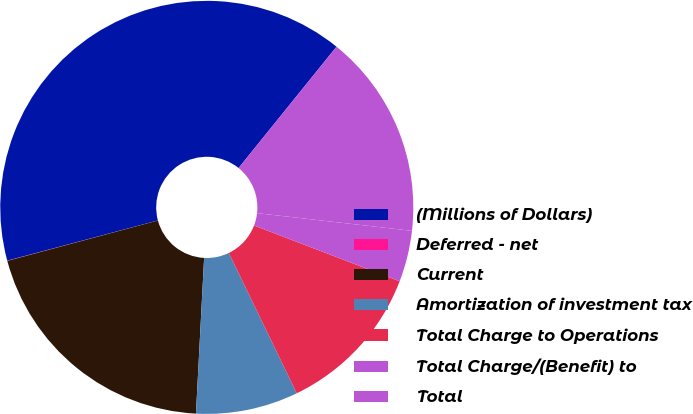Convert chart to OTSL. <chart><loc_0><loc_0><loc_500><loc_500><pie_chart><fcel>(Millions of Dollars)<fcel>Deferred - net<fcel>Current<fcel>Amortization of investment tax<fcel>Total Charge to Operations<fcel>Total Charge/(Benefit) to<fcel>Total<nl><fcel>39.96%<fcel>0.02%<fcel>19.99%<fcel>8.01%<fcel>12.0%<fcel>4.01%<fcel>16.0%<nl></chart> 